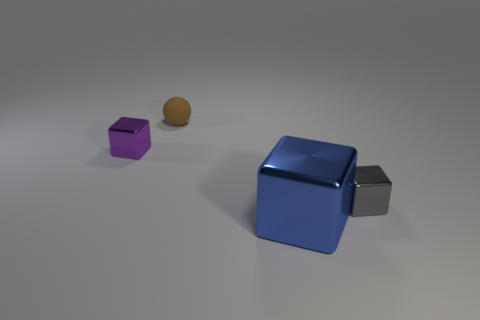Subtract all small purple blocks. How many blocks are left? 2 Add 4 red matte cylinders. How many objects exist? 8 Subtract all green blocks. Subtract all green cylinders. How many blocks are left? 3 Subtract all cubes. How many objects are left? 1 Add 1 metallic blocks. How many metallic blocks exist? 4 Subtract 0 blue balls. How many objects are left? 4 Subtract all tiny blue metallic cylinders. Subtract all tiny rubber spheres. How many objects are left? 3 Add 3 blue blocks. How many blue blocks are left? 4 